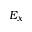Convert formula to latex. <formula><loc_0><loc_0><loc_500><loc_500>E _ { x }</formula> 